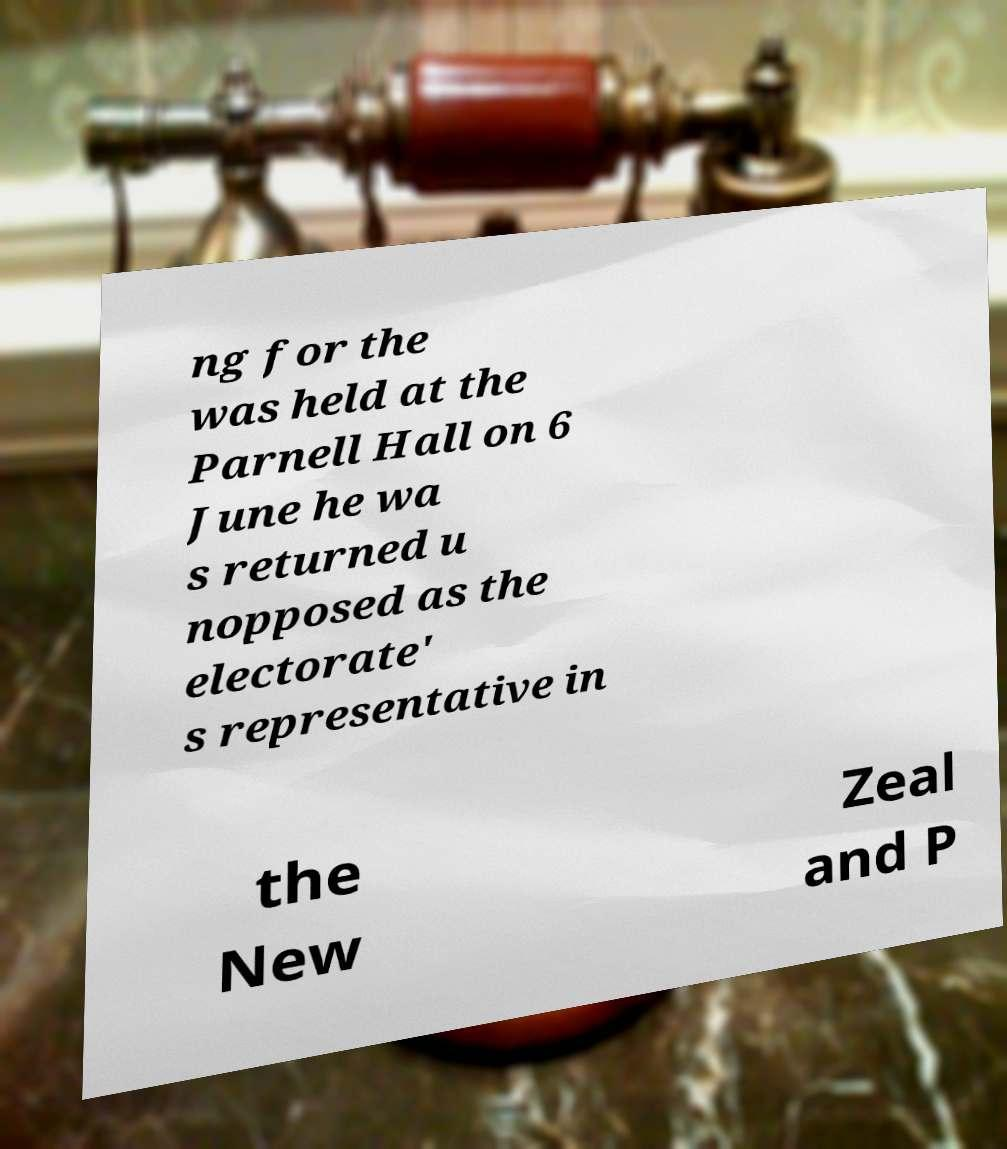Please identify and transcribe the text found in this image. ng for the was held at the Parnell Hall on 6 June he wa s returned u nopposed as the electorate' s representative in the New Zeal and P 